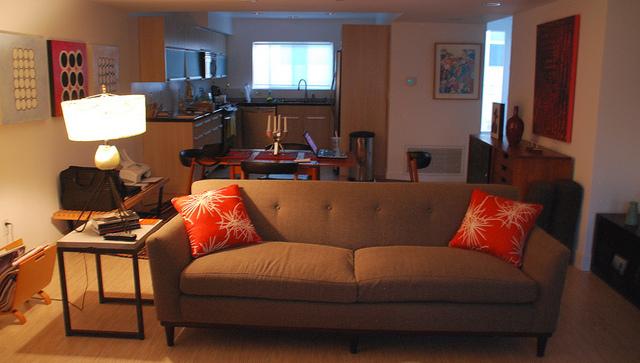Which room is this?
Concise answer only. Living room. Is anyone sitting on the sofa?
Concise answer only. No. What colors are the pillows on the sofa?
Quick response, please. Red and white. 